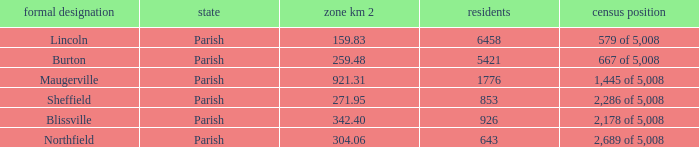What is the status(es) of the place with an area of 304.06 km2? Parish. Help me parse the entirety of this table. {'header': ['formal designation', 'state', 'zone km 2', 'residents', 'census position'], 'rows': [['Lincoln', 'Parish', '159.83', '6458', '579 of 5,008'], ['Burton', 'Parish', '259.48', '5421', '667 of 5,008'], ['Maugerville', 'Parish', '921.31', '1776', '1,445 of 5,008'], ['Sheffield', 'Parish', '271.95', '853', '2,286 of 5,008'], ['Blissville', 'Parish', '342.40', '926', '2,178 of 5,008'], ['Northfield', 'Parish', '304.06', '643', '2,689 of 5,008']]} 